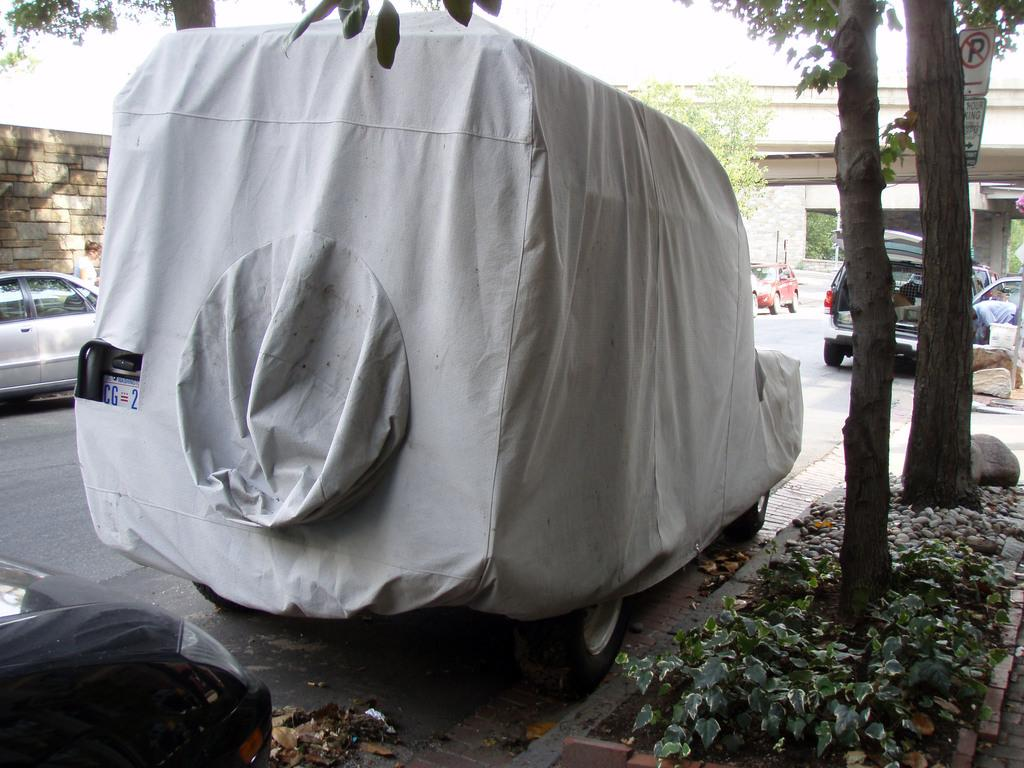What can be seen on the road in the image? There are fleets of vehicles on the road in the image. What type of barrier is present in the image? There is a fence in the image. What type of vegetation is visible in the image? There are trees in the image. What type of signage is present in the image? There are boards in the image. What structure can be seen in the background of the image? There is a bridge visible in the background of the image. What is visible in the sky in the image? The sky is visible in the background of the image. What type of print can be seen on the bridge in the image? There is no print visible on the bridge in the image. How does the day balance itself in the image? The concept of "day balancing" is not applicable in the context of the image, as it is a static representation of a scene. 